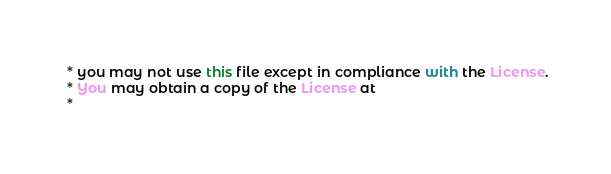Convert code to text. <code><loc_0><loc_0><loc_500><loc_500><_Scala_> * you may not use this file except in compliance with the License.
 * You may obtain a copy of the License at
 *</code> 